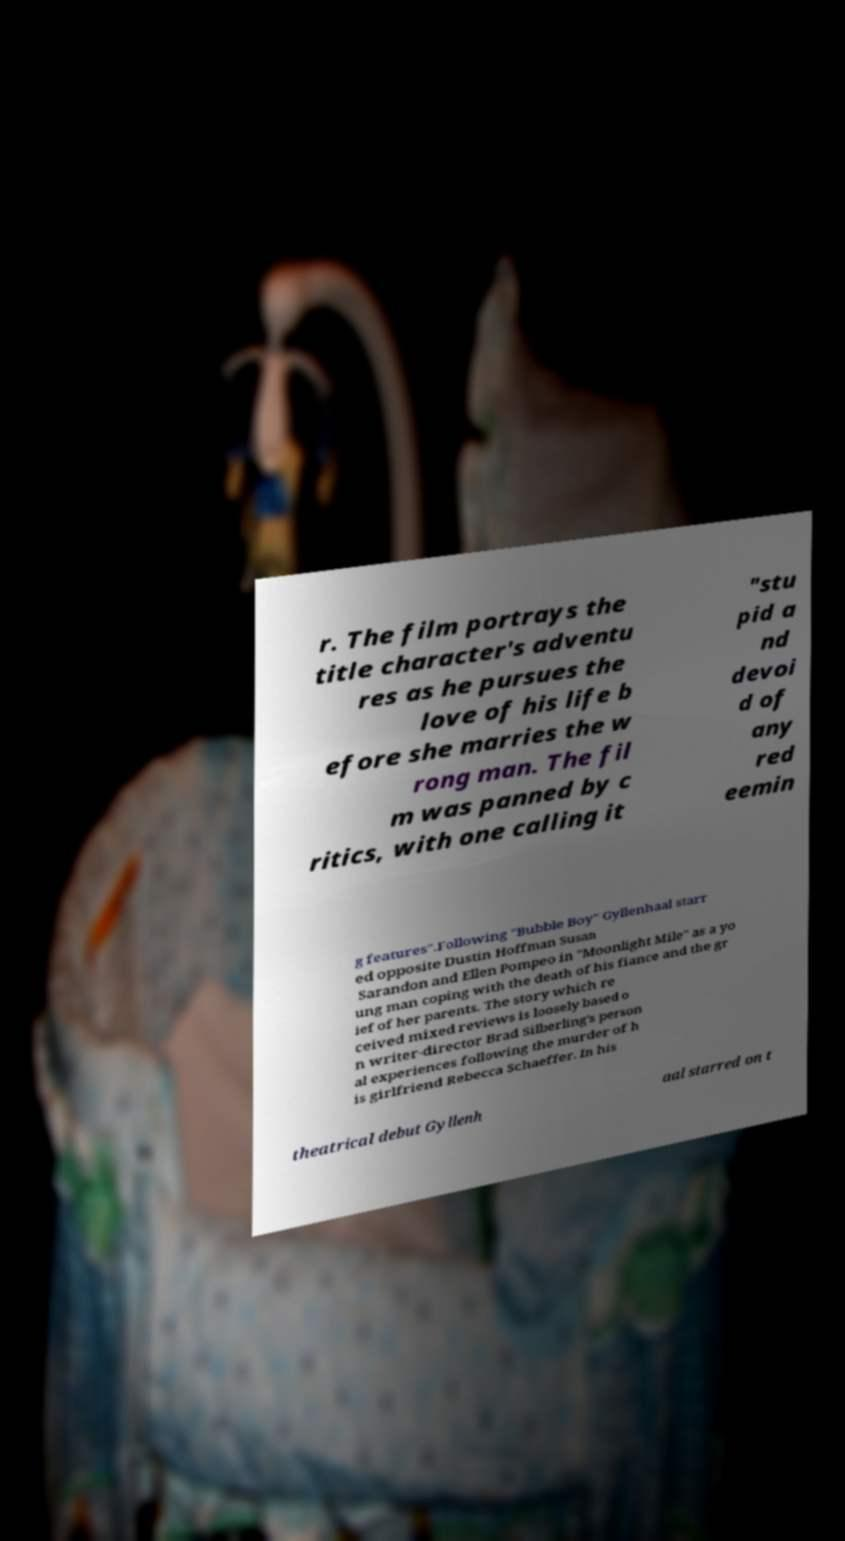I need the written content from this picture converted into text. Can you do that? r. The film portrays the title character's adventu res as he pursues the love of his life b efore she marries the w rong man. The fil m was panned by c ritics, with one calling it "stu pid a nd devoi d of any red eemin g features".Following "Bubble Boy" Gyllenhaal starr ed opposite Dustin Hoffman Susan Sarandon and Ellen Pompeo in "Moonlight Mile" as a yo ung man coping with the death of his fiance and the gr ief of her parents. The story which re ceived mixed reviews is loosely based o n writer-director Brad Silberling's person al experiences following the murder of h is girlfriend Rebecca Schaeffer. In his theatrical debut Gyllenh aal starred on t 